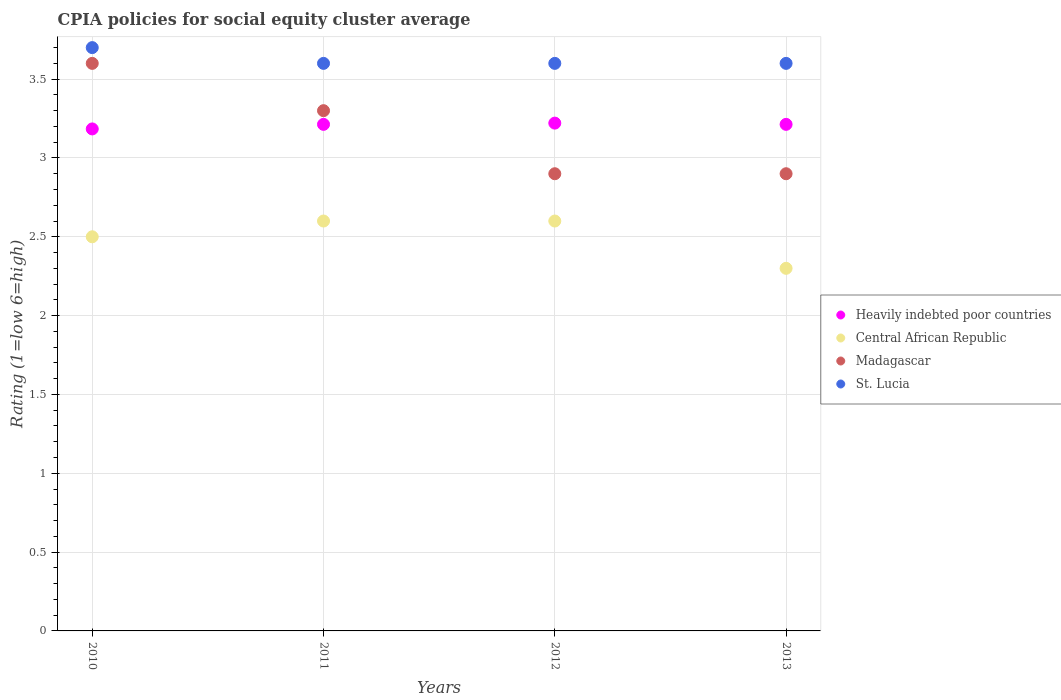What is the CPIA rating in Heavily indebted poor countries in 2013?
Your answer should be compact. 3.21. Across all years, what is the maximum CPIA rating in Heavily indebted poor countries?
Provide a short and direct response. 3.22. Across all years, what is the minimum CPIA rating in St. Lucia?
Give a very brief answer. 3.6. What is the difference between the CPIA rating in Central African Republic in 2011 and that in 2013?
Ensure brevity in your answer.  0.3. What is the difference between the CPIA rating in St. Lucia in 2013 and the CPIA rating in Madagascar in 2010?
Your answer should be compact. 0. What is the average CPIA rating in Madagascar per year?
Make the answer very short. 3.18. In the year 2011, what is the difference between the CPIA rating in Central African Republic and CPIA rating in St. Lucia?
Provide a short and direct response. -1. In how many years, is the CPIA rating in Central African Republic greater than 2.5?
Give a very brief answer. 2. What is the ratio of the CPIA rating in Heavily indebted poor countries in 2011 to that in 2012?
Offer a terse response. 1. What is the difference between the highest and the second highest CPIA rating in Heavily indebted poor countries?
Make the answer very short. 0.01. What is the difference between the highest and the lowest CPIA rating in Central African Republic?
Offer a terse response. 0.3. In how many years, is the CPIA rating in St. Lucia greater than the average CPIA rating in St. Lucia taken over all years?
Your answer should be very brief. 1. Is the sum of the CPIA rating in St. Lucia in 2010 and 2012 greater than the maximum CPIA rating in Heavily indebted poor countries across all years?
Your response must be concise. Yes. Is it the case that in every year, the sum of the CPIA rating in Central African Republic and CPIA rating in St. Lucia  is greater than the sum of CPIA rating in Heavily indebted poor countries and CPIA rating in Madagascar?
Provide a short and direct response. No. How many years are there in the graph?
Offer a terse response. 4. Are the values on the major ticks of Y-axis written in scientific E-notation?
Keep it short and to the point. No. Does the graph contain any zero values?
Provide a short and direct response. No. Does the graph contain grids?
Give a very brief answer. Yes. Where does the legend appear in the graph?
Offer a very short reply. Center right. How many legend labels are there?
Your answer should be very brief. 4. What is the title of the graph?
Your answer should be compact. CPIA policies for social equity cluster average. Does "South Sudan" appear as one of the legend labels in the graph?
Provide a short and direct response. No. What is the label or title of the X-axis?
Provide a succinct answer. Years. What is the label or title of the Y-axis?
Provide a succinct answer. Rating (1=low 6=high). What is the Rating (1=low 6=high) of Heavily indebted poor countries in 2010?
Your answer should be very brief. 3.18. What is the Rating (1=low 6=high) in Central African Republic in 2010?
Offer a very short reply. 2.5. What is the Rating (1=low 6=high) in Madagascar in 2010?
Make the answer very short. 3.6. What is the Rating (1=low 6=high) in St. Lucia in 2010?
Provide a short and direct response. 3.7. What is the Rating (1=low 6=high) in Heavily indebted poor countries in 2011?
Your answer should be very brief. 3.21. What is the Rating (1=low 6=high) in Madagascar in 2011?
Your answer should be compact. 3.3. What is the Rating (1=low 6=high) in Heavily indebted poor countries in 2012?
Ensure brevity in your answer.  3.22. What is the Rating (1=low 6=high) in Madagascar in 2012?
Give a very brief answer. 2.9. What is the Rating (1=low 6=high) of Heavily indebted poor countries in 2013?
Give a very brief answer. 3.21. What is the Rating (1=low 6=high) of Central African Republic in 2013?
Provide a short and direct response. 2.3. What is the Rating (1=low 6=high) in St. Lucia in 2013?
Offer a terse response. 3.6. Across all years, what is the maximum Rating (1=low 6=high) of Heavily indebted poor countries?
Your response must be concise. 3.22. Across all years, what is the maximum Rating (1=low 6=high) in Madagascar?
Keep it short and to the point. 3.6. Across all years, what is the minimum Rating (1=low 6=high) of Heavily indebted poor countries?
Keep it short and to the point. 3.18. What is the total Rating (1=low 6=high) in Heavily indebted poor countries in the graph?
Make the answer very short. 12.83. What is the total Rating (1=low 6=high) in Madagascar in the graph?
Give a very brief answer. 12.7. What is the difference between the Rating (1=low 6=high) of Heavily indebted poor countries in 2010 and that in 2011?
Offer a very short reply. -0.03. What is the difference between the Rating (1=low 6=high) of Central African Republic in 2010 and that in 2011?
Offer a very short reply. -0.1. What is the difference between the Rating (1=low 6=high) of St. Lucia in 2010 and that in 2011?
Provide a succinct answer. 0.1. What is the difference between the Rating (1=low 6=high) in Heavily indebted poor countries in 2010 and that in 2012?
Provide a succinct answer. -0.04. What is the difference between the Rating (1=low 6=high) of Heavily indebted poor countries in 2010 and that in 2013?
Offer a terse response. -0.03. What is the difference between the Rating (1=low 6=high) in St. Lucia in 2010 and that in 2013?
Your response must be concise. 0.1. What is the difference between the Rating (1=low 6=high) of Heavily indebted poor countries in 2011 and that in 2012?
Ensure brevity in your answer.  -0.01. What is the difference between the Rating (1=low 6=high) in Central African Republic in 2011 and that in 2012?
Keep it short and to the point. 0. What is the difference between the Rating (1=low 6=high) of Madagascar in 2011 and that in 2012?
Make the answer very short. 0.4. What is the difference between the Rating (1=low 6=high) of Central African Republic in 2011 and that in 2013?
Keep it short and to the point. 0.3. What is the difference between the Rating (1=low 6=high) of Madagascar in 2011 and that in 2013?
Give a very brief answer. 0.4. What is the difference between the Rating (1=low 6=high) of Heavily indebted poor countries in 2012 and that in 2013?
Keep it short and to the point. 0.01. What is the difference between the Rating (1=low 6=high) of Madagascar in 2012 and that in 2013?
Your answer should be compact. 0. What is the difference between the Rating (1=low 6=high) of St. Lucia in 2012 and that in 2013?
Provide a short and direct response. 0. What is the difference between the Rating (1=low 6=high) in Heavily indebted poor countries in 2010 and the Rating (1=low 6=high) in Central African Republic in 2011?
Offer a very short reply. 0.58. What is the difference between the Rating (1=low 6=high) of Heavily indebted poor countries in 2010 and the Rating (1=low 6=high) of Madagascar in 2011?
Provide a succinct answer. -0.12. What is the difference between the Rating (1=low 6=high) of Heavily indebted poor countries in 2010 and the Rating (1=low 6=high) of St. Lucia in 2011?
Provide a short and direct response. -0.42. What is the difference between the Rating (1=low 6=high) of Central African Republic in 2010 and the Rating (1=low 6=high) of St. Lucia in 2011?
Offer a terse response. -1.1. What is the difference between the Rating (1=low 6=high) of Madagascar in 2010 and the Rating (1=low 6=high) of St. Lucia in 2011?
Provide a short and direct response. 0. What is the difference between the Rating (1=low 6=high) in Heavily indebted poor countries in 2010 and the Rating (1=low 6=high) in Central African Republic in 2012?
Provide a succinct answer. 0.58. What is the difference between the Rating (1=low 6=high) in Heavily indebted poor countries in 2010 and the Rating (1=low 6=high) in Madagascar in 2012?
Make the answer very short. 0.28. What is the difference between the Rating (1=low 6=high) of Heavily indebted poor countries in 2010 and the Rating (1=low 6=high) of St. Lucia in 2012?
Make the answer very short. -0.42. What is the difference between the Rating (1=low 6=high) of Central African Republic in 2010 and the Rating (1=low 6=high) of Madagascar in 2012?
Provide a succinct answer. -0.4. What is the difference between the Rating (1=low 6=high) of Madagascar in 2010 and the Rating (1=low 6=high) of St. Lucia in 2012?
Give a very brief answer. 0. What is the difference between the Rating (1=low 6=high) in Heavily indebted poor countries in 2010 and the Rating (1=low 6=high) in Central African Republic in 2013?
Your response must be concise. 0.88. What is the difference between the Rating (1=low 6=high) of Heavily indebted poor countries in 2010 and the Rating (1=low 6=high) of Madagascar in 2013?
Ensure brevity in your answer.  0.28. What is the difference between the Rating (1=low 6=high) of Heavily indebted poor countries in 2010 and the Rating (1=low 6=high) of St. Lucia in 2013?
Your response must be concise. -0.42. What is the difference between the Rating (1=low 6=high) in Heavily indebted poor countries in 2011 and the Rating (1=low 6=high) in Central African Republic in 2012?
Keep it short and to the point. 0.61. What is the difference between the Rating (1=low 6=high) of Heavily indebted poor countries in 2011 and the Rating (1=low 6=high) of Madagascar in 2012?
Keep it short and to the point. 0.31. What is the difference between the Rating (1=low 6=high) of Heavily indebted poor countries in 2011 and the Rating (1=low 6=high) of St. Lucia in 2012?
Offer a very short reply. -0.39. What is the difference between the Rating (1=low 6=high) of Central African Republic in 2011 and the Rating (1=low 6=high) of St. Lucia in 2012?
Offer a terse response. -1. What is the difference between the Rating (1=low 6=high) of Madagascar in 2011 and the Rating (1=low 6=high) of St. Lucia in 2012?
Offer a very short reply. -0.3. What is the difference between the Rating (1=low 6=high) of Heavily indebted poor countries in 2011 and the Rating (1=low 6=high) of Central African Republic in 2013?
Your answer should be very brief. 0.91. What is the difference between the Rating (1=low 6=high) of Heavily indebted poor countries in 2011 and the Rating (1=low 6=high) of Madagascar in 2013?
Your answer should be compact. 0.31. What is the difference between the Rating (1=low 6=high) in Heavily indebted poor countries in 2011 and the Rating (1=low 6=high) in St. Lucia in 2013?
Provide a succinct answer. -0.39. What is the difference between the Rating (1=low 6=high) in Central African Republic in 2011 and the Rating (1=low 6=high) in Madagascar in 2013?
Your answer should be compact. -0.3. What is the difference between the Rating (1=low 6=high) of Madagascar in 2011 and the Rating (1=low 6=high) of St. Lucia in 2013?
Give a very brief answer. -0.3. What is the difference between the Rating (1=low 6=high) of Heavily indebted poor countries in 2012 and the Rating (1=low 6=high) of Central African Republic in 2013?
Keep it short and to the point. 0.92. What is the difference between the Rating (1=low 6=high) in Heavily indebted poor countries in 2012 and the Rating (1=low 6=high) in Madagascar in 2013?
Your answer should be very brief. 0.32. What is the difference between the Rating (1=low 6=high) of Heavily indebted poor countries in 2012 and the Rating (1=low 6=high) of St. Lucia in 2013?
Give a very brief answer. -0.38. What is the difference between the Rating (1=low 6=high) of Central African Republic in 2012 and the Rating (1=low 6=high) of Madagascar in 2013?
Offer a very short reply. -0.3. What is the difference between the Rating (1=low 6=high) of Central African Republic in 2012 and the Rating (1=low 6=high) of St. Lucia in 2013?
Make the answer very short. -1. What is the difference between the Rating (1=low 6=high) of Madagascar in 2012 and the Rating (1=low 6=high) of St. Lucia in 2013?
Your answer should be very brief. -0.7. What is the average Rating (1=low 6=high) of Heavily indebted poor countries per year?
Make the answer very short. 3.21. What is the average Rating (1=low 6=high) in Central African Republic per year?
Offer a terse response. 2.5. What is the average Rating (1=low 6=high) in Madagascar per year?
Make the answer very short. 3.17. What is the average Rating (1=low 6=high) of St. Lucia per year?
Offer a terse response. 3.62. In the year 2010, what is the difference between the Rating (1=low 6=high) in Heavily indebted poor countries and Rating (1=low 6=high) in Central African Republic?
Your answer should be compact. 0.68. In the year 2010, what is the difference between the Rating (1=low 6=high) in Heavily indebted poor countries and Rating (1=low 6=high) in Madagascar?
Provide a short and direct response. -0.42. In the year 2010, what is the difference between the Rating (1=low 6=high) in Heavily indebted poor countries and Rating (1=low 6=high) in St. Lucia?
Keep it short and to the point. -0.52. In the year 2010, what is the difference between the Rating (1=low 6=high) of Central African Republic and Rating (1=low 6=high) of Madagascar?
Your answer should be compact. -1.1. In the year 2010, what is the difference between the Rating (1=low 6=high) of Central African Republic and Rating (1=low 6=high) of St. Lucia?
Your answer should be very brief. -1.2. In the year 2011, what is the difference between the Rating (1=low 6=high) in Heavily indebted poor countries and Rating (1=low 6=high) in Central African Republic?
Make the answer very short. 0.61. In the year 2011, what is the difference between the Rating (1=low 6=high) in Heavily indebted poor countries and Rating (1=low 6=high) in Madagascar?
Ensure brevity in your answer.  -0.09. In the year 2011, what is the difference between the Rating (1=low 6=high) of Heavily indebted poor countries and Rating (1=low 6=high) of St. Lucia?
Provide a short and direct response. -0.39. In the year 2011, what is the difference between the Rating (1=low 6=high) in Central African Republic and Rating (1=low 6=high) in St. Lucia?
Provide a short and direct response. -1. In the year 2012, what is the difference between the Rating (1=low 6=high) of Heavily indebted poor countries and Rating (1=low 6=high) of Central African Republic?
Make the answer very short. 0.62. In the year 2012, what is the difference between the Rating (1=low 6=high) of Heavily indebted poor countries and Rating (1=low 6=high) of Madagascar?
Offer a very short reply. 0.32. In the year 2012, what is the difference between the Rating (1=low 6=high) of Heavily indebted poor countries and Rating (1=low 6=high) of St. Lucia?
Offer a very short reply. -0.38. In the year 2012, what is the difference between the Rating (1=low 6=high) of Central African Republic and Rating (1=low 6=high) of St. Lucia?
Your response must be concise. -1. In the year 2012, what is the difference between the Rating (1=low 6=high) of Madagascar and Rating (1=low 6=high) of St. Lucia?
Offer a very short reply. -0.7. In the year 2013, what is the difference between the Rating (1=low 6=high) in Heavily indebted poor countries and Rating (1=low 6=high) in Central African Republic?
Your answer should be very brief. 0.91. In the year 2013, what is the difference between the Rating (1=low 6=high) of Heavily indebted poor countries and Rating (1=low 6=high) of Madagascar?
Provide a succinct answer. 0.31. In the year 2013, what is the difference between the Rating (1=low 6=high) of Heavily indebted poor countries and Rating (1=low 6=high) of St. Lucia?
Make the answer very short. -0.39. In the year 2013, what is the difference between the Rating (1=low 6=high) of Central African Republic and Rating (1=low 6=high) of Madagascar?
Keep it short and to the point. -0.6. What is the ratio of the Rating (1=low 6=high) of Central African Republic in 2010 to that in 2011?
Offer a terse response. 0.96. What is the ratio of the Rating (1=low 6=high) of St. Lucia in 2010 to that in 2011?
Provide a short and direct response. 1.03. What is the ratio of the Rating (1=low 6=high) of Central African Republic in 2010 to that in 2012?
Your answer should be compact. 0.96. What is the ratio of the Rating (1=low 6=high) in Madagascar in 2010 to that in 2012?
Your answer should be very brief. 1.24. What is the ratio of the Rating (1=low 6=high) in St. Lucia in 2010 to that in 2012?
Offer a very short reply. 1.03. What is the ratio of the Rating (1=low 6=high) in Heavily indebted poor countries in 2010 to that in 2013?
Provide a short and direct response. 0.99. What is the ratio of the Rating (1=low 6=high) of Central African Republic in 2010 to that in 2013?
Give a very brief answer. 1.09. What is the ratio of the Rating (1=low 6=high) of Madagascar in 2010 to that in 2013?
Your answer should be very brief. 1.24. What is the ratio of the Rating (1=low 6=high) of St. Lucia in 2010 to that in 2013?
Provide a succinct answer. 1.03. What is the ratio of the Rating (1=low 6=high) in Heavily indebted poor countries in 2011 to that in 2012?
Keep it short and to the point. 1. What is the ratio of the Rating (1=low 6=high) in Central African Republic in 2011 to that in 2012?
Give a very brief answer. 1. What is the ratio of the Rating (1=low 6=high) in Madagascar in 2011 to that in 2012?
Your answer should be very brief. 1.14. What is the ratio of the Rating (1=low 6=high) of Heavily indebted poor countries in 2011 to that in 2013?
Give a very brief answer. 1. What is the ratio of the Rating (1=low 6=high) of Central African Republic in 2011 to that in 2013?
Keep it short and to the point. 1.13. What is the ratio of the Rating (1=low 6=high) in Madagascar in 2011 to that in 2013?
Offer a terse response. 1.14. What is the ratio of the Rating (1=low 6=high) of Heavily indebted poor countries in 2012 to that in 2013?
Give a very brief answer. 1. What is the ratio of the Rating (1=low 6=high) of Central African Republic in 2012 to that in 2013?
Ensure brevity in your answer.  1.13. What is the ratio of the Rating (1=low 6=high) in St. Lucia in 2012 to that in 2013?
Your answer should be compact. 1. What is the difference between the highest and the second highest Rating (1=low 6=high) of Heavily indebted poor countries?
Give a very brief answer. 0.01. What is the difference between the highest and the second highest Rating (1=low 6=high) of Madagascar?
Provide a succinct answer. 0.3. What is the difference between the highest and the lowest Rating (1=low 6=high) in Heavily indebted poor countries?
Your answer should be compact. 0.04. What is the difference between the highest and the lowest Rating (1=low 6=high) of Madagascar?
Offer a terse response. 0.7. What is the difference between the highest and the lowest Rating (1=low 6=high) in St. Lucia?
Make the answer very short. 0.1. 